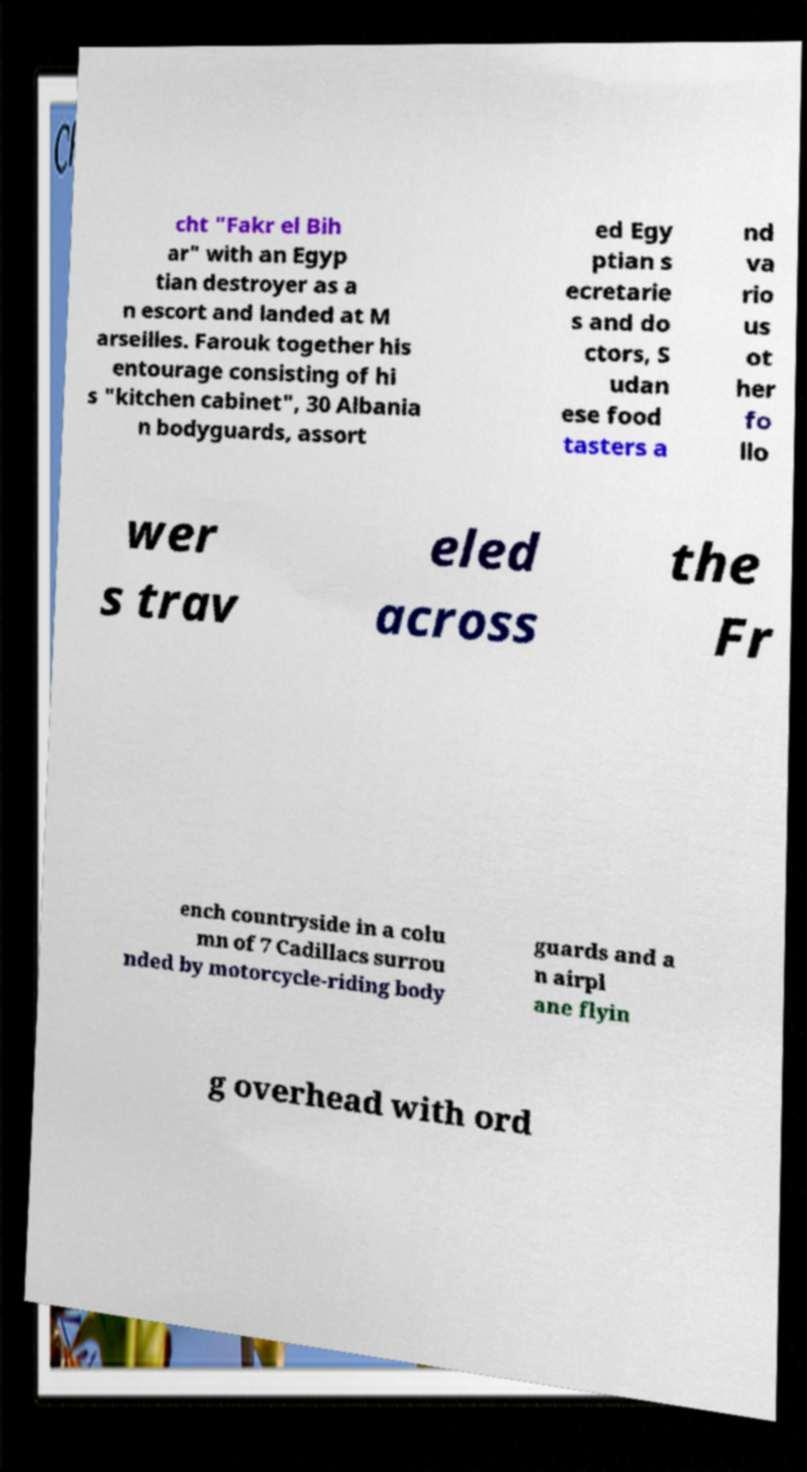Please read and relay the text visible in this image. What does it say? cht "Fakr el Bih ar" with an Egyp tian destroyer as a n escort and landed at M arseilles. Farouk together his entourage consisting of hi s "kitchen cabinet", 30 Albania n bodyguards, assort ed Egy ptian s ecretarie s and do ctors, S udan ese food tasters a nd va rio us ot her fo llo wer s trav eled across the Fr ench countryside in a colu mn of 7 Cadillacs surrou nded by motorcycle-riding body guards and a n airpl ane flyin g overhead with ord 